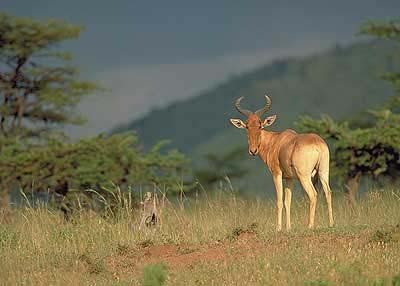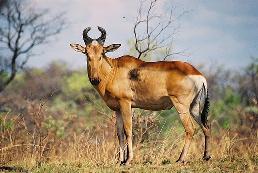The first image is the image on the left, the second image is the image on the right. Examine the images to the left and right. Is the description "There are exactly two animals." accurate? Answer yes or no. Yes. The first image is the image on the left, the second image is the image on the right. For the images shown, is this caption "There are at most 2 animals in the image pair" true? Answer yes or no. Yes. 